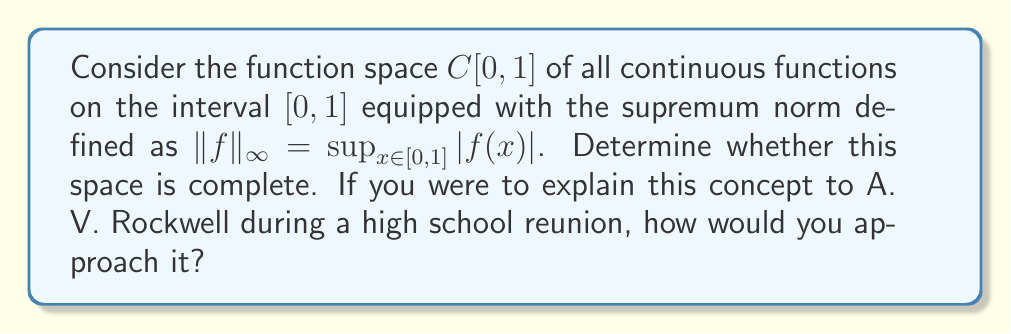Give your solution to this math problem. To determine the completeness of $C[0,1]$ with the supremum norm, we need to show that every Cauchy sequence in this space converges to an element within the space. Let's break this down step-by-step:

1) First, recall that a sequence $(f_n)$ in $C[0,1]$ is Cauchy if for every $\epsilon > 0$, there exists an $N \in \mathbb{N}$ such that for all $m,n \geq N$, we have $\|f_m - f_n\|_{\infty} < \epsilon$.

2) Now, let's consider an arbitrary Cauchy sequence $(f_n)$ in $C[0,1]$.

3) For any fixed $x \in [0,1]$, $(f_n(x))$ is a Cauchy sequence in $\mathbb{R}$. This is because for any $\epsilon > 0$, there exists an $N$ such that for all $m,n \geq N$, we have:

   $|f_m(x) - f_n(x)| \leq \sup_{y \in [0,1]} |f_m(y) - f_n(y)| = \|f_m - f_n\|_{\infty} < \epsilon$

4) Since $\mathbb{R}$ is complete, $(f_n(x))$ converges to some real number for each $x \in [0,1]$. Let's call this limit $f(x)$.

5) We now have a function $f:[0,1] \to \mathbb{R}$ defined pointwise as the limit of $f_n$.

6) To show that $f \in C[0,1]$, we need to prove that $f$ is continuous. This can be done using the uniform convergence of $f_n$ to $f$, which follows from the Cauchy property.

7) Finally, we need to show that $f_n$ converges to $f$ in the supremum norm. This again follows from the Cauchy property of $(f_n)$.

Therefore, we have shown that every Cauchy sequence in $C[0,1]$ converges to a function in $C[0,1]$, proving that this space is complete.

To explain this to A. V. Rockwell at a high school reunion, you might say: "Remember how we learned about continuous functions in calculus? Well, imagine a space containing all these functions on a fixed interval. It turns out that if you take any sequence of these functions that get arbitrarily close to each other (in a precise mathematical sense), they always converge to another continuous function in this space. That's what we mean by completeness, and it's a crucial property in advanced mathematics!"
Answer: The function space $C[0,1]$ equipped with the supremum norm is complete. 